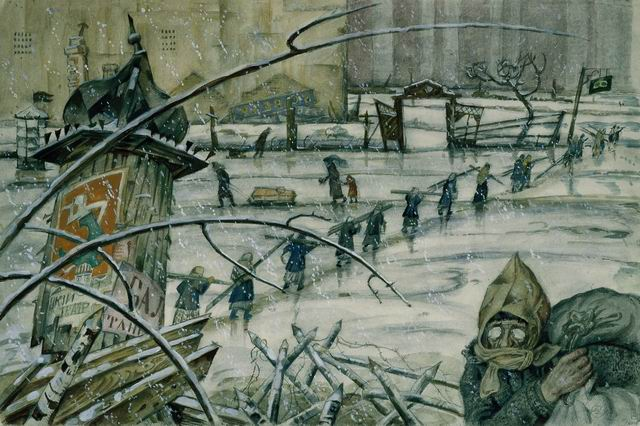What are the key elements in this picture? The image depicts a bleak, wartime cityscape under heavy snowfall. Key elements include a line of people trudging through the snow, many of whom appear to be carrying heavy sacks, suggesting hardship or evacuation. In the foreground, a person wearing a gas mask and heavy winter clothing is visible, adding an element of danger or chemical warfare to the scene. Broken branches, a dilapidated poster board, and scattered debris underscore the sense of destruction. The background shows large, ominous buildings and stark trees, enhancing the overall atmosphere of desolation and struggle. The artist's use of subdued colors and detailed representation of the snow and environment effectively convey the harsh conditions and grim mood. 